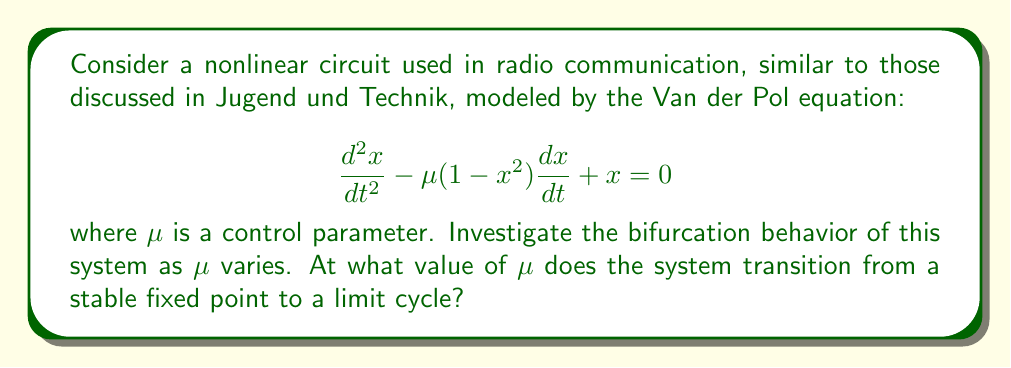Teach me how to tackle this problem. 1. The Van der Pol equation describes a self-oscillating system, common in radio circuits.

2. For small $\mu$, the system has a stable fixed point at the origin (0,0).

3. As $\mu$ increases, the system undergoes a Hopf bifurcation, transitioning to a limit cycle.

4. To find the bifurcation point, we linearize the system around the fixed point:

   Let $y = \frac{dx}{dt}$, then:
   $$\frac{dx}{dt} = y$$
   $$\frac{dy}{dt} = \mu(1-x^2)y - x$$

5. The Jacobian matrix at (0,0) is:
   $$J = \begin{pmatrix}
   0 & 1 \\
   -1 & \mu
   \end{pmatrix}$$

6. The characteristic equation is:
   $$\lambda^2 - \mu\lambda + 1 = 0$$

7. For a Hopf bifurcation, the eigenvalues should be purely imaginary. This occurs when:
   $$\mu = 0$$

8. At this point, the eigenvalues are $\lambda = \pm i$.

9. For $\mu < 0$, the fixed point is stable. For $\mu > 0$, it becomes unstable, and a stable limit cycle emerges.
Answer: $\mu = 0$ 